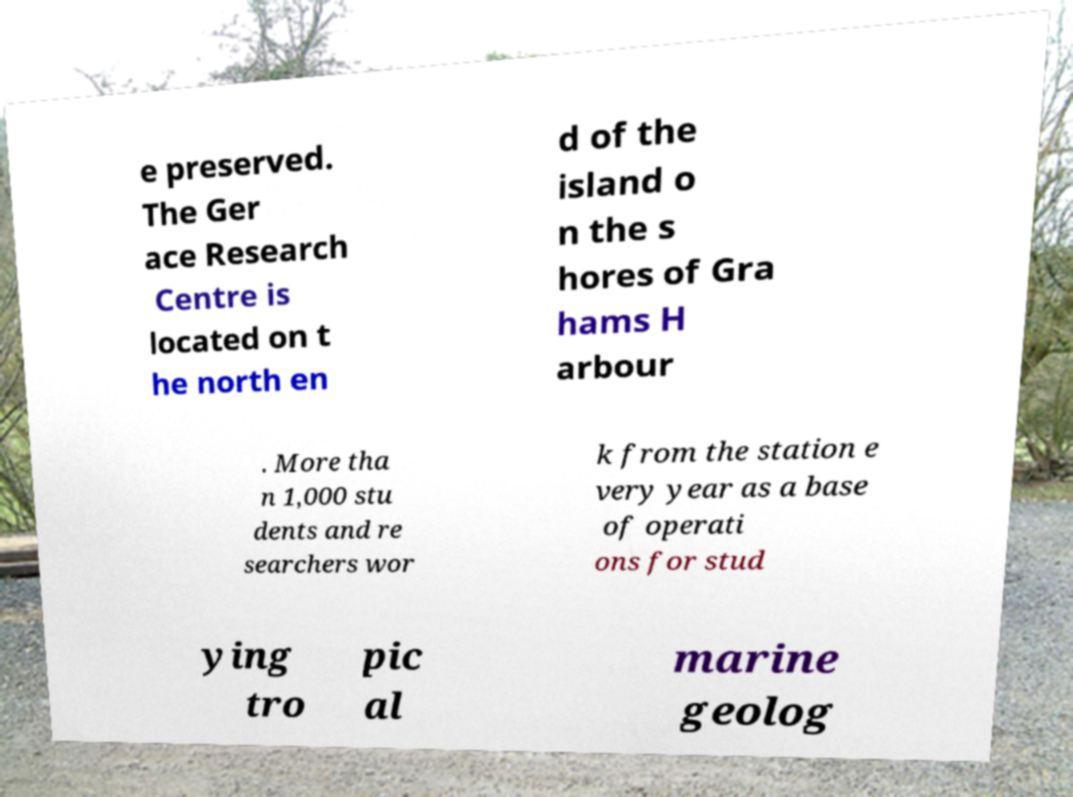There's text embedded in this image that I need extracted. Can you transcribe it verbatim? e preserved. The Ger ace Research Centre is located on t he north en d of the island o n the s hores of Gra hams H arbour . More tha n 1,000 stu dents and re searchers wor k from the station e very year as a base of operati ons for stud ying tro pic al marine geolog 